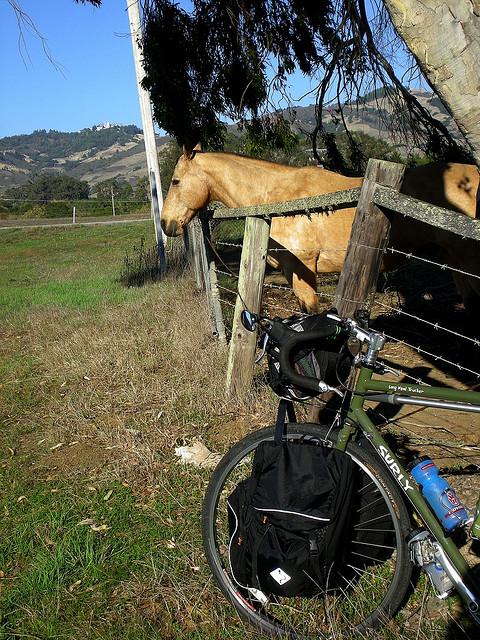What kind of fence is shown?
Keep it brief. Wood. What animals can be seen?
Keep it brief. Horse. Is there a bike nearby?
Be succinct. Yes. 